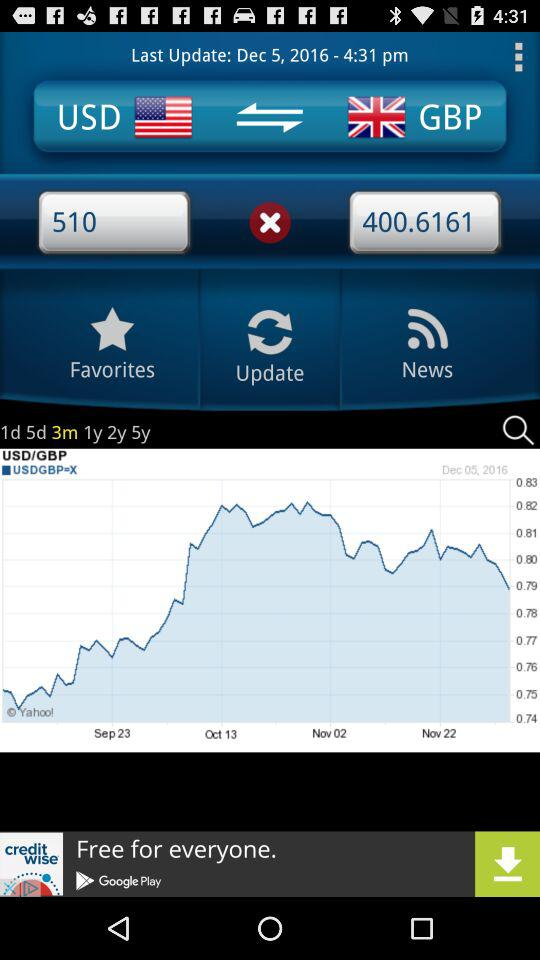Between which countries does the currency conversion take place? The currency conversion takes place between the United States of America and the United Kingdom. 